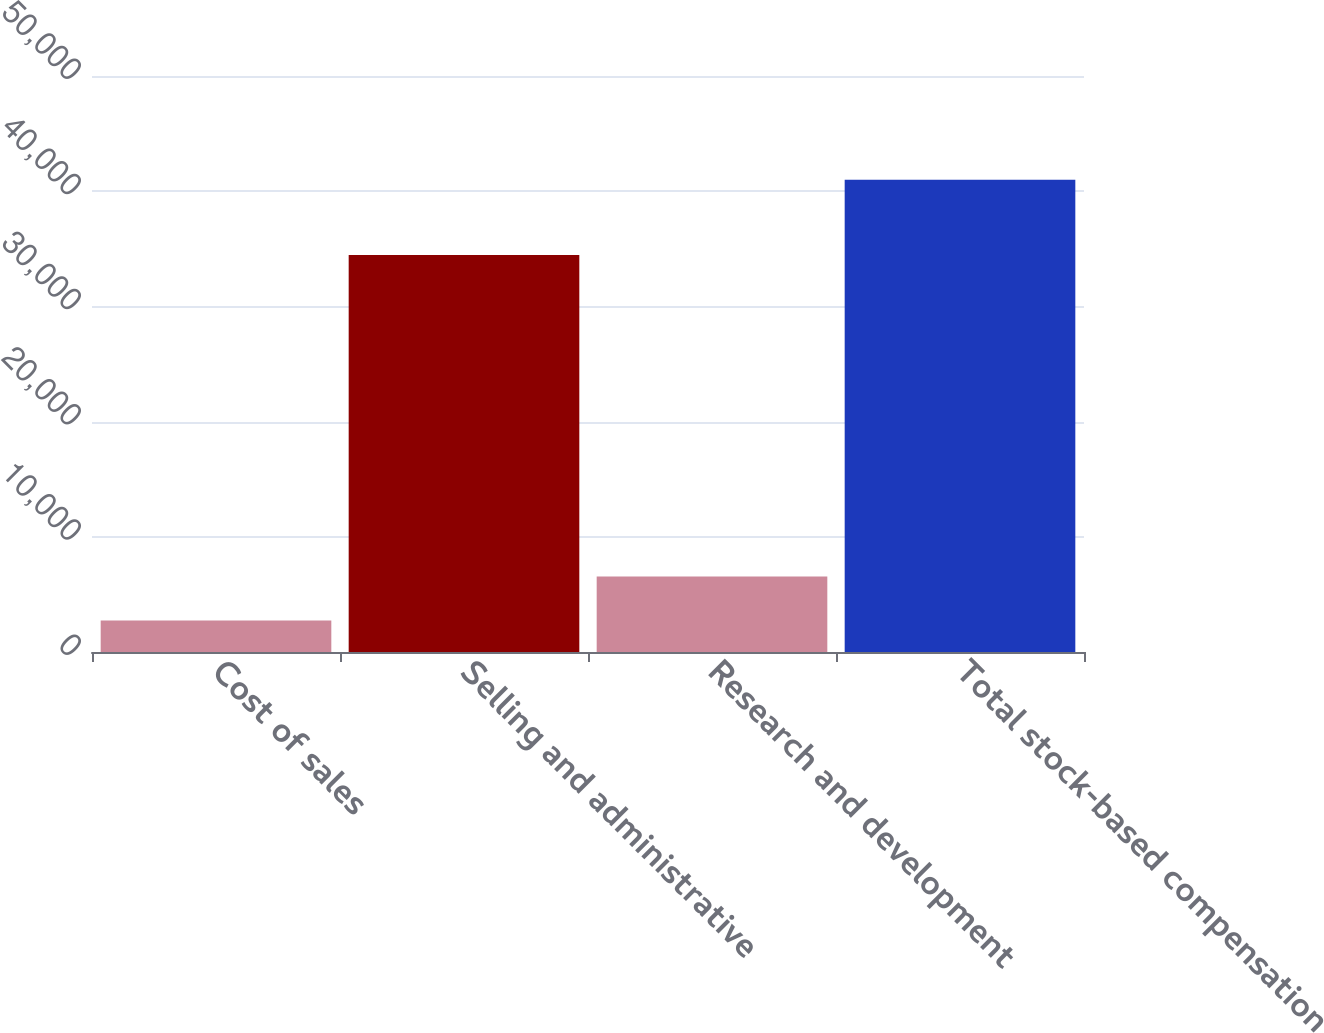<chart> <loc_0><loc_0><loc_500><loc_500><bar_chart><fcel>Cost of sales<fcel>Selling and administrative<fcel>Research and development<fcel>Total stock-based compensation<nl><fcel>2738<fcel>34451<fcel>6564<fcel>40998<nl></chart> 